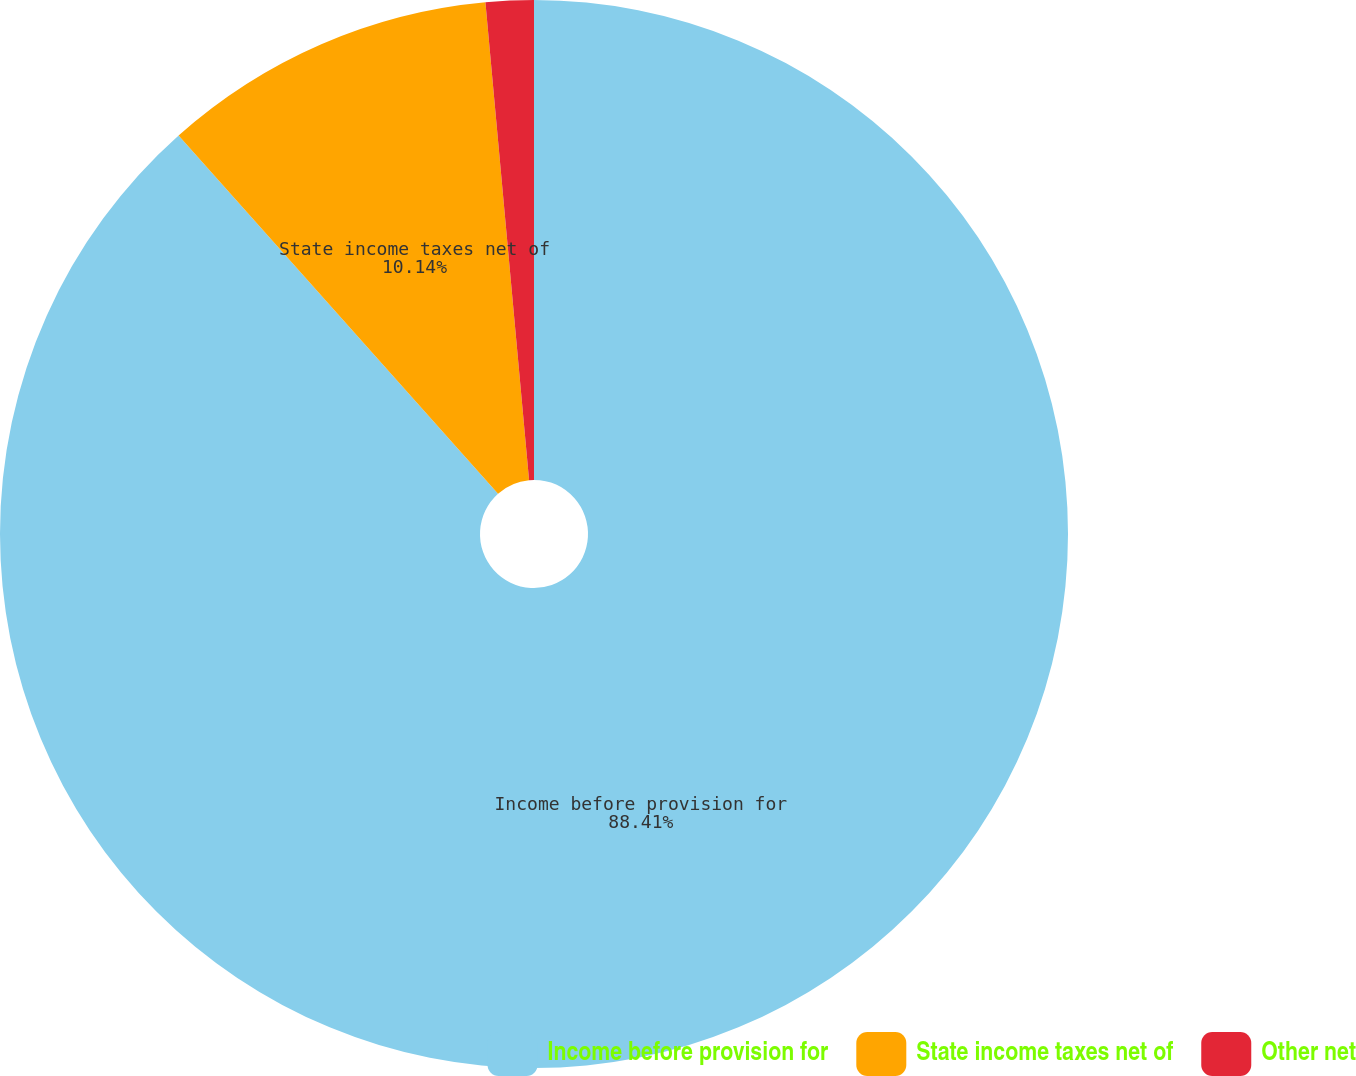Convert chart to OTSL. <chart><loc_0><loc_0><loc_500><loc_500><pie_chart><fcel>Income before provision for<fcel>State income taxes net of<fcel>Other net<nl><fcel>88.41%<fcel>10.14%<fcel>1.45%<nl></chart> 